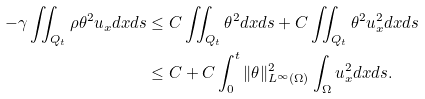Convert formula to latex. <formula><loc_0><loc_0><loc_500><loc_500>- \gamma \iint _ { Q _ { t } } \rho \theta ^ { 2 } u _ { x } d x d s & \leq C \iint _ { Q _ { t } } \theta ^ { 2 } d x d s + C \iint _ { Q _ { t } } \theta ^ { 2 } u _ { x } ^ { 2 } d x d s \\ & \leq C + C \int _ { 0 } ^ { t } \| \theta \| _ { L ^ { \infty } ( \Omega ) } ^ { 2 } \int _ { \Omega } u _ { x } ^ { 2 } d x d s .</formula> 